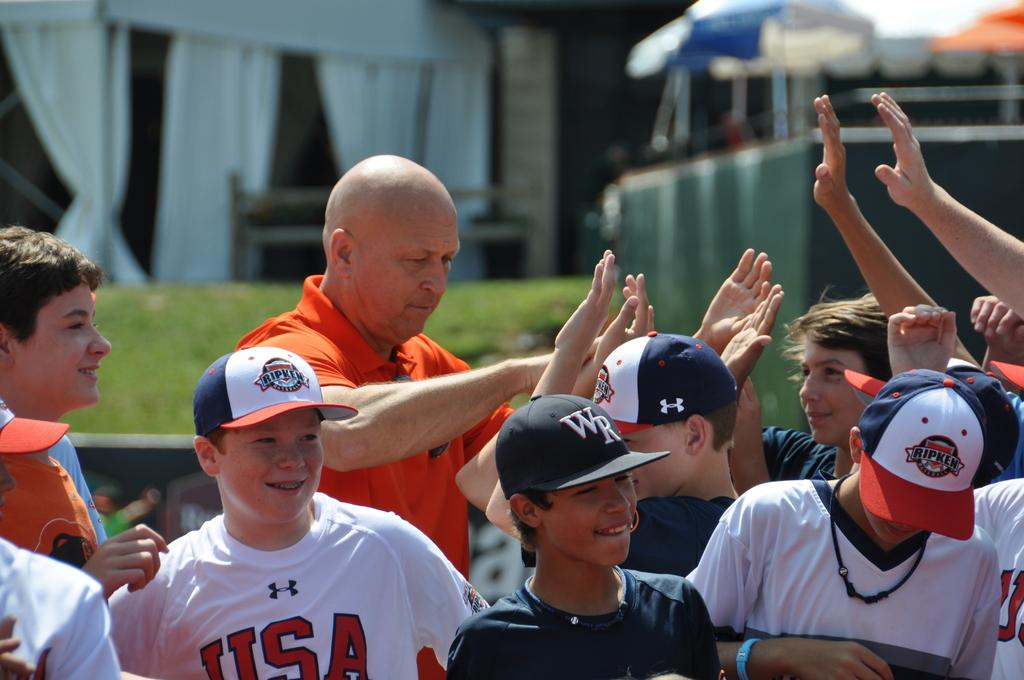<image>
Relay a brief, clear account of the picture shown. One of the children is wearing a white shirt with USA on it 